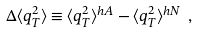<formula> <loc_0><loc_0><loc_500><loc_500>\Delta \langle q _ { T } ^ { 2 } \rangle \equiv \langle q _ { T } ^ { 2 } \rangle ^ { h A } - \langle q _ { T } ^ { 2 } \rangle ^ { h N } \ ,</formula> 